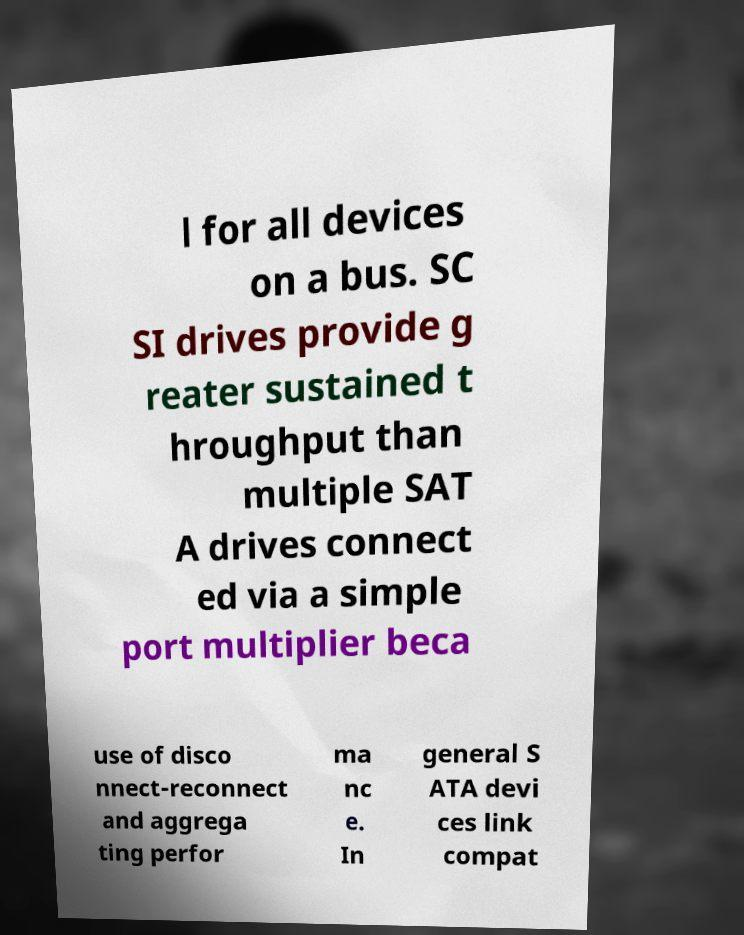Can you accurately transcribe the text from the provided image for me? l for all devices on a bus. SC SI drives provide g reater sustained t hroughput than multiple SAT A drives connect ed via a simple port multiplier beca use of disco nnect-reconnect and aggrega ting perfor ma nc e. In general S ATA devi ces link compat 